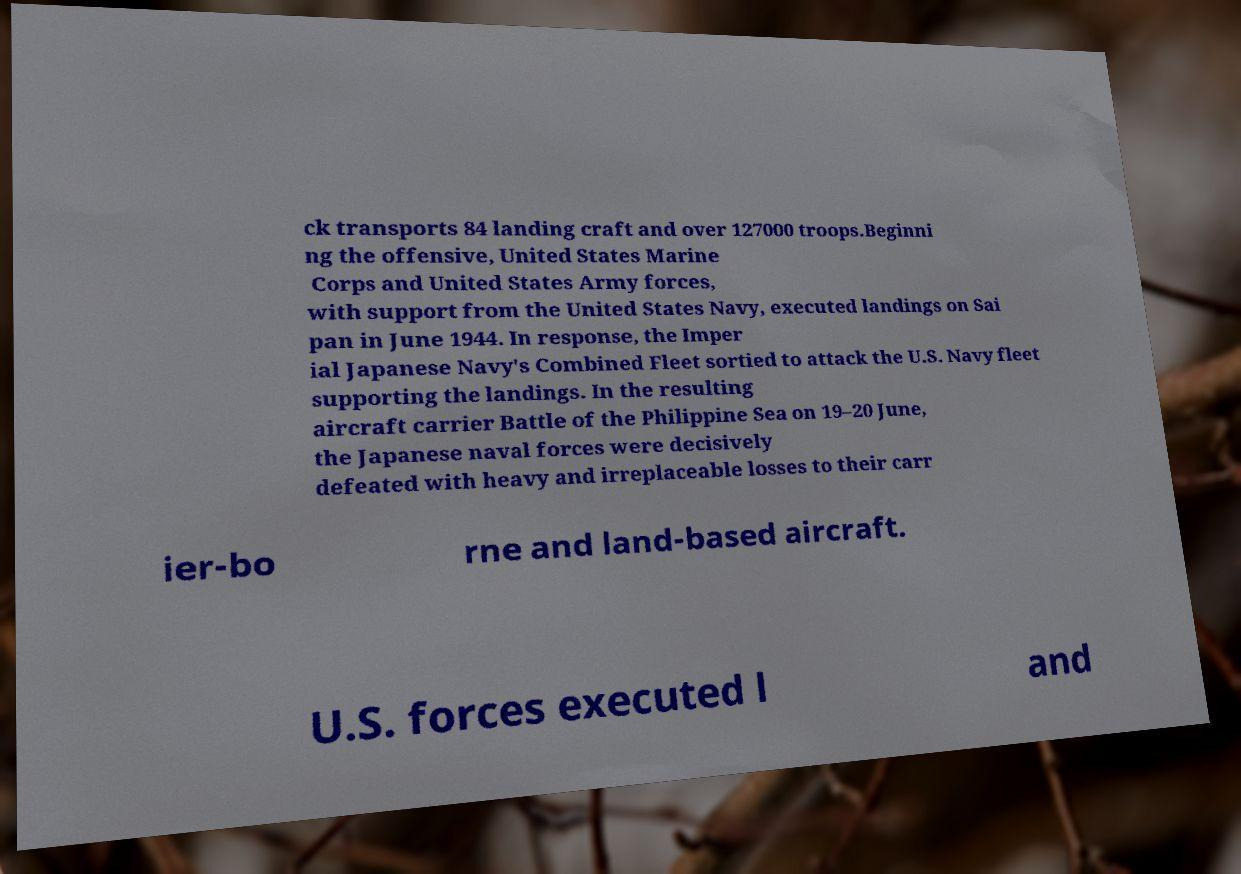Please read and relay the text visible in this image. What does it say? ck transports 84 landing craft and over 127000 troops.Beginni ng the offensive, United States Marine Corps and United States Army forces, with support from the United States Navy, executed landings on Sai pan in June 1944. In response, the Imper ial Japanese Navy's Combined Fleet sortied to attack the U.S. Navy fleet supporting the landings. In the resulting aircraft carrier Battle of the Philippine Sea on 19–20 June, the Japanese naval forces were decisively defeated with heavy and irreplaceable losses to their carr ier-bo rne and land-based aircraft. U.S. forces executed l and 